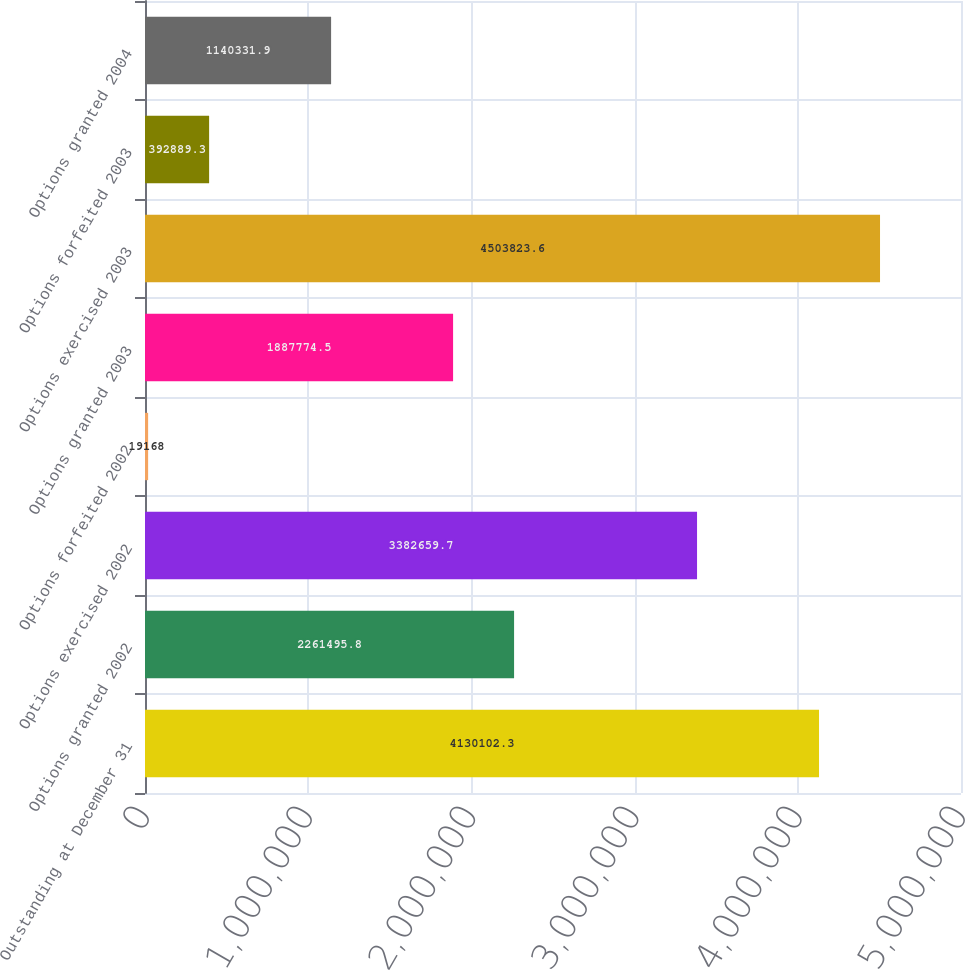Convert chart to OTSL. <chart><loc_0><loc_0><loc_500><loc_500><bar_chart><fcel>Outstanding at December 31<fcel>Options granted 2002<fcel>Options exercised 2002<fcel>Options forfeited 2002<fcel>Options granted 2003<fcel>Options exercised 2003<fcel>Options forfeited 2003<fcel>Options granted 2004<nl><fcel>4.1301e+06<fcel>2.2615e+06<fcel>3.38266e+06<fcel>19168<fcel>1.88777e+06<fcel>4.50382e+06<fcel>392889<fcel>1.14033e+06<nl></chart> 